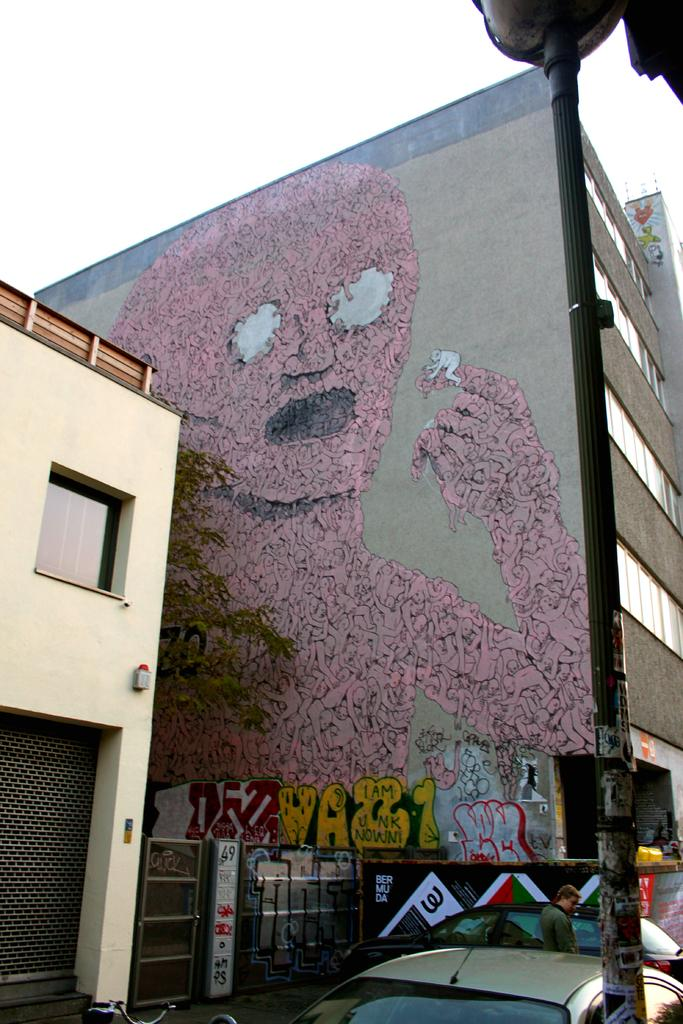What type of structures can be seen in the image? There are buildings in the image. What type of vehicles are visible at the bottom of the image? Cars are visible at the bottom of the image. Can you describe the person in the image? There is a person in the image. What is located on the right side of the image? There is a pole on the right side of the image. What is visible in the background of the image? The sky is visible in the background of the image. Where is the pipe located in the image? There is no pipe present in the image. What type of recess can be seen in the image? There is no recess present in the image. 